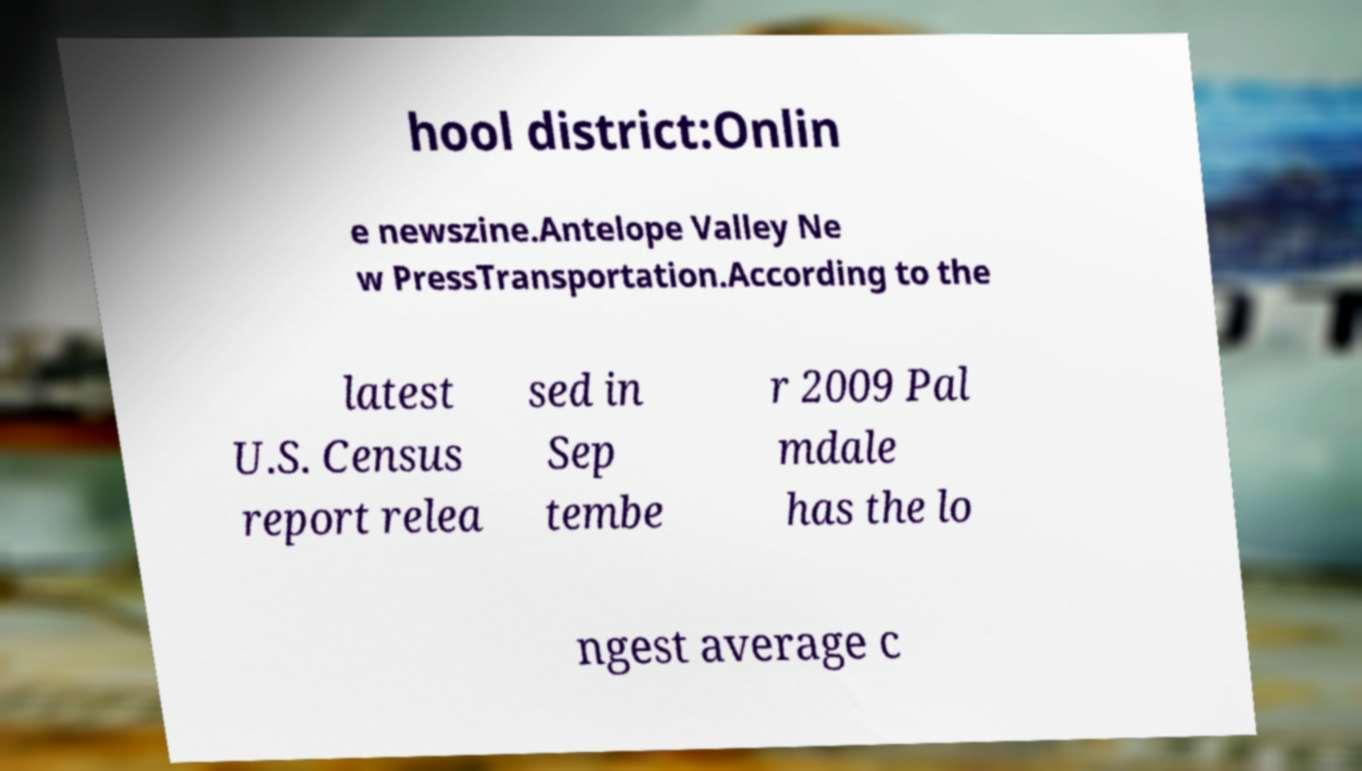Can you accurately transcribe the text from the provided image for me? hool district:Onlin e newszine.Antelope Valley Ne w PressTransportation.According to the latest U.S. Census report relea sed in Sep tembe r 2009 Pal mdale has the lo ngest average c 